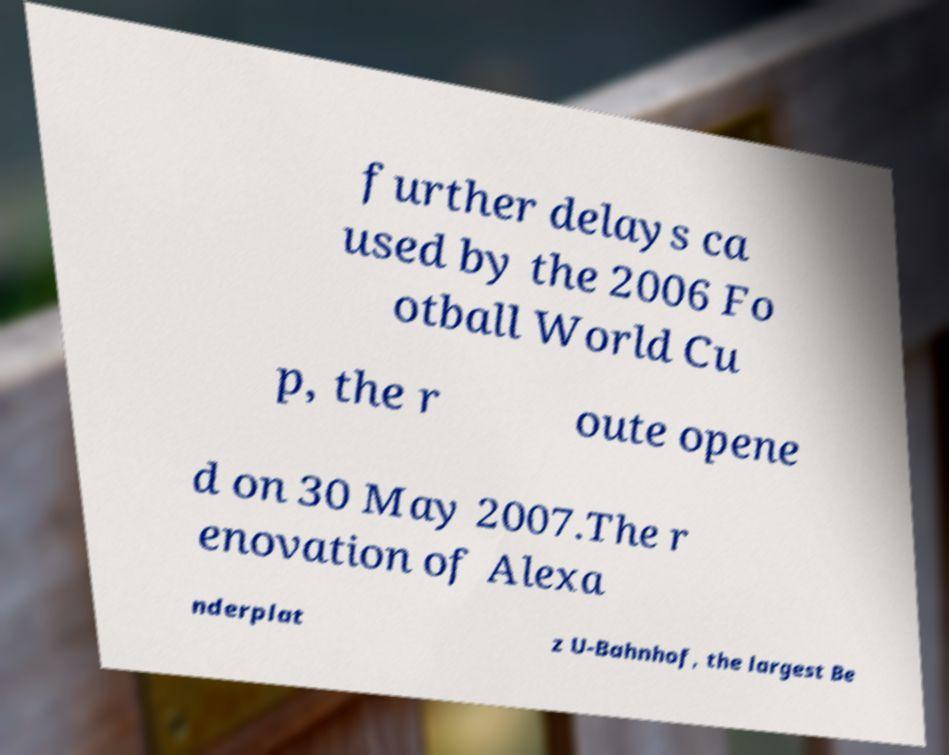There's text embedded in this image that I need extracted. Can you transcribe it verbatim? further delays ca used by the 2006 Fo otball World Cu p, the r oute opene d on 30 May 2007.The r enovation of Alexa nderplat z U-Bahnhof, the largest Be 